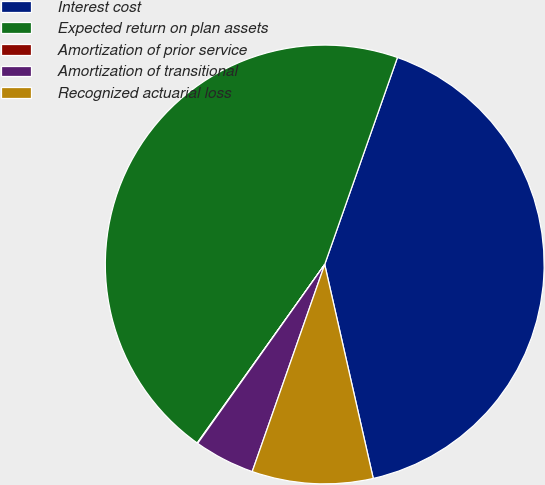Convert chart. <chart><loc_0><loc_0><loc_500><loc_500><pie_chart><fcel>Interest cost<fcel>Expected return on plan assets<fcel>Amortization of prior service<fcel>Amortization of transitional<fcel>Recognized actuarial loss<nl><fcel>41.07%<fcel>45.51%<fcel>0.04%<fcel>4.47%<fcel>8.91%<nl></chart> 